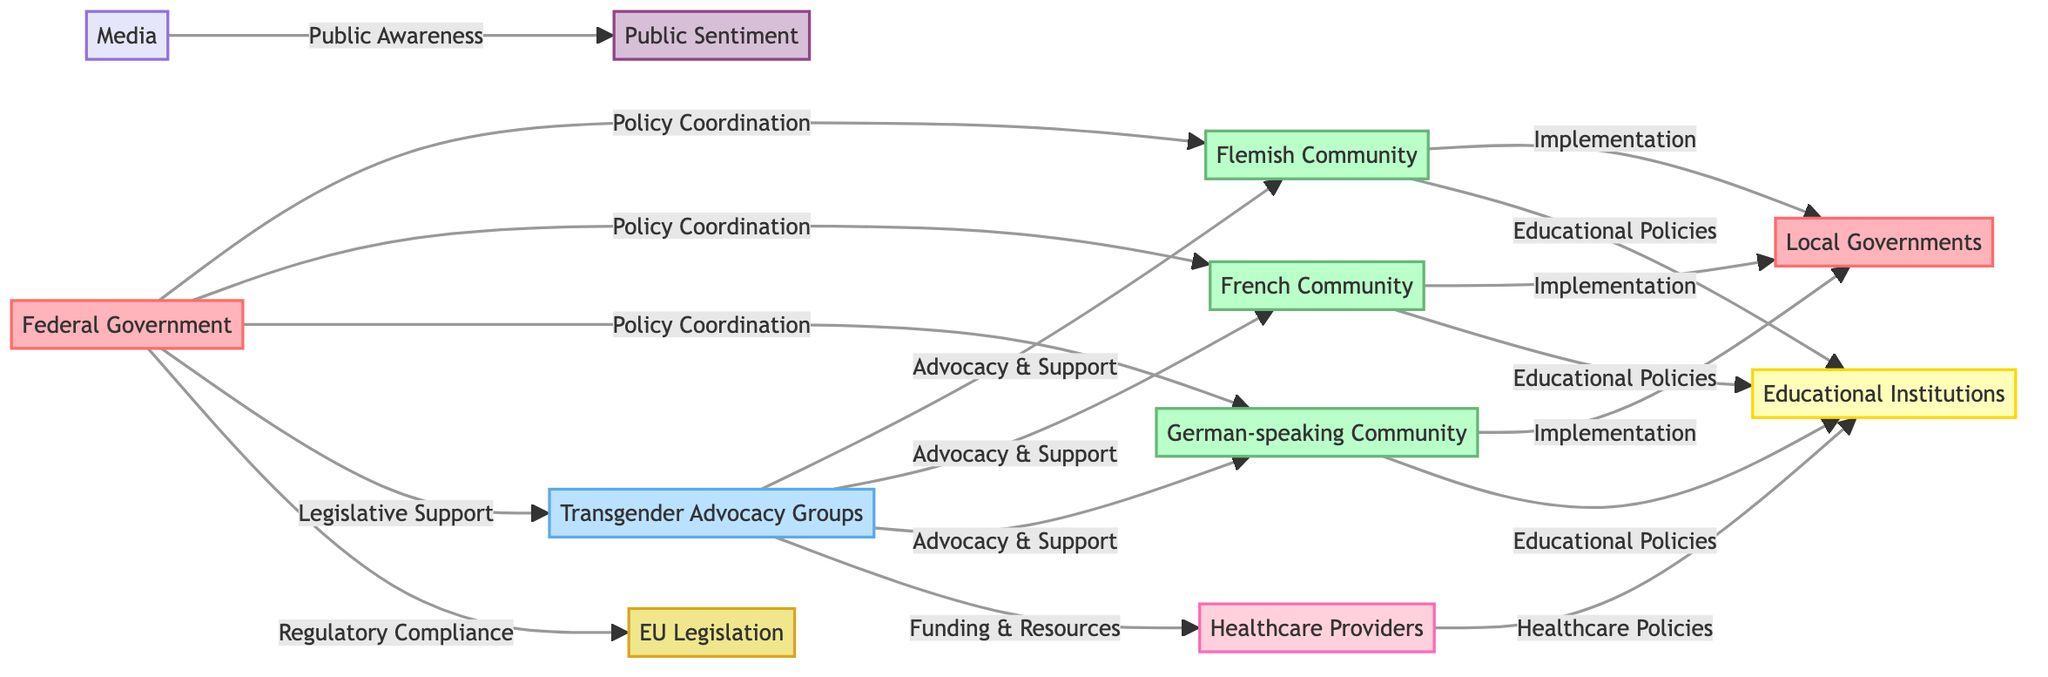What node represents the central authority for national policies, including transgender rights? The node labeled "Federal Government" identifies the central authority responsible for national policies, including those concerning transgender rights.
Answer: Federal Government How many regional communities are involved in the diagram? There are three regional communities mentioned: the Flemish Community, the French Community, and the German-speaking Community.
Answer: 3 Which nodes have a direct policy relationship with the Federal Government? The diagram shows three regional communities (Flemish Community, French Community, German-speaking Community) and one advocacy group (Transgender Advocacy Groups) that have direct policy relationships with the Federal Government.
Answer: Flemish Community, French Community, German-speaking Community, Transgender Advocacy Groups What kind of support do Transgender Advocacy Groups provide to Healthcare Providers? According to the diagram, the Transgender Advocacy Groups provide "Funding & Resources" to Healthcare Providers.
Answer: Funding & Resources What is the public influence of media on public sentiment towards transgender issues? The arrow between the Media and Public Sentiment nodes is labeled "Public Awareness," indicating that media outlets help shape public perception and awareness of transgender rights.
Answer: Public Awareness Which node coordinates its policies with the German-speaking Community? The German-speaking Community coordinates its policies with the Federal Government and the Transgender Advocacy Groups as shown in the diagram.
Answer: Federal Government, Transgender Advocacy Groups How is public sentiment influenced by media according to the diagram? The relationship is indicated by the edge labeled "Public Awareness," which shows that media influences public sentiment regarding transgender rights.
Answer: Public Awareness What are the types of policies implemented by Local Governments? Local Governments implement the policies from the regional communities such as the Flemish Community, French Community, and German-speaking Community, specifically regarding transgender rights.
Answer: Implementation What entity ensures regulatory compliance with EU legislation? The Federal Government ensures compliance with the EU legislation, as indicated by the edge labeled "Regulatory Compliance" connecting these two nodes.
Answer: Federal Government 